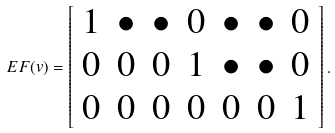<formula> <loc_0><loc_0><loc_500><loc_500>E F ( v ) = \left [ \begin{array} { c c c c c c c } 1 & \bullet & \bullet & 0 & \bullet & \bullet & 0 \\ 0 & 0 & 0 & 1 & \bullet & \bullet & 0 \\ 0 & 0 & 0 & 0 & 0 & 0 & 1 \end{array} \right ] .</formula> 